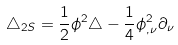<formula> <loc_0><loc_0><loc_500><loc_500>\triangle _ { 2 S } = \frac { 1 } { 2 } \phi ^ { 2 } \triangle - \frac { 1 } { 4 } \phi ^ { 2 } _ { , \nu } \partial _ { \nu }</formula> 